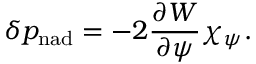<formula> <loc_0><loc_0><loc_500><loc_500>\delta p _ { n a d } = - 2 \frac { \partial W } { \partial \psi } \chi _ { \psi } .</formula> 